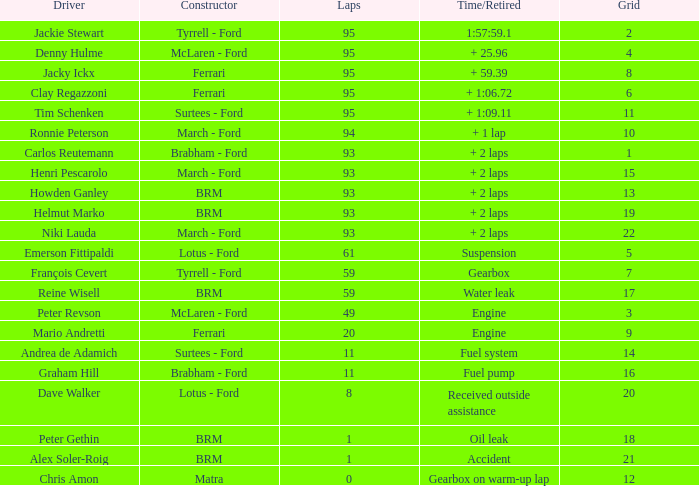What is the total number of grids for peter gethin? 18.0. 